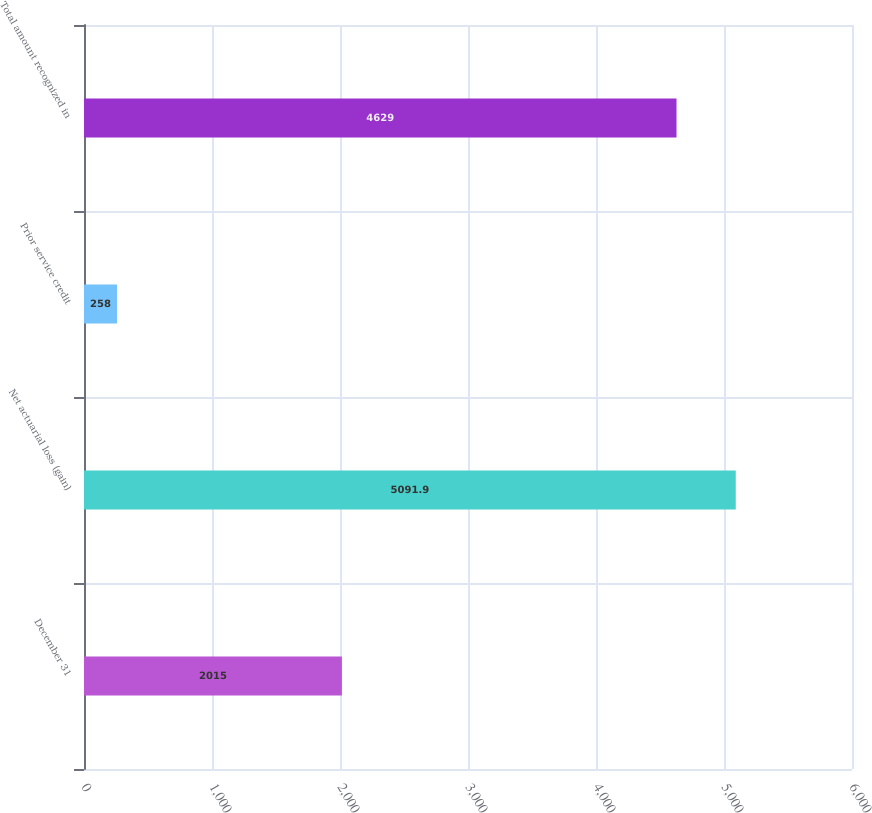Convert chart to OTSL. <chart><loc_0><loc_0><loc_500><loc_500><bar_chart><fcel>December 31<fcel>Net actuarial loss (gain)<fcel>Prior service credit<fcel>Total amount recognized in<nl><fcel>2015<fcel>5091.9<fcel>258<fcel>4629<nl></chart> 